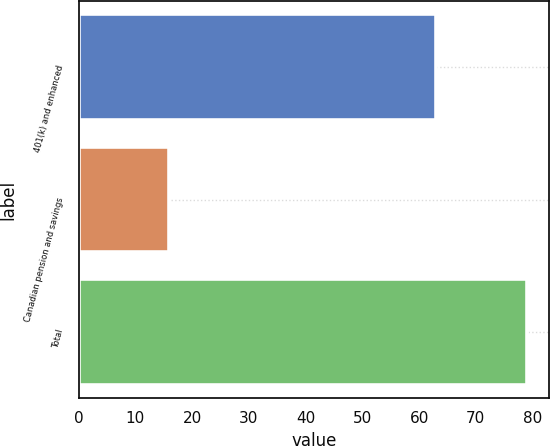Convert chart to OTSL. <chart><loc_0><loc_0><loc_500><loc_500><bar_chart><fcel>401(k) and enhanced<fcel>Canadian pension and savings<fcel>Total<nl><fcel>63<fcel>16<fcel>79<nl></chart> 